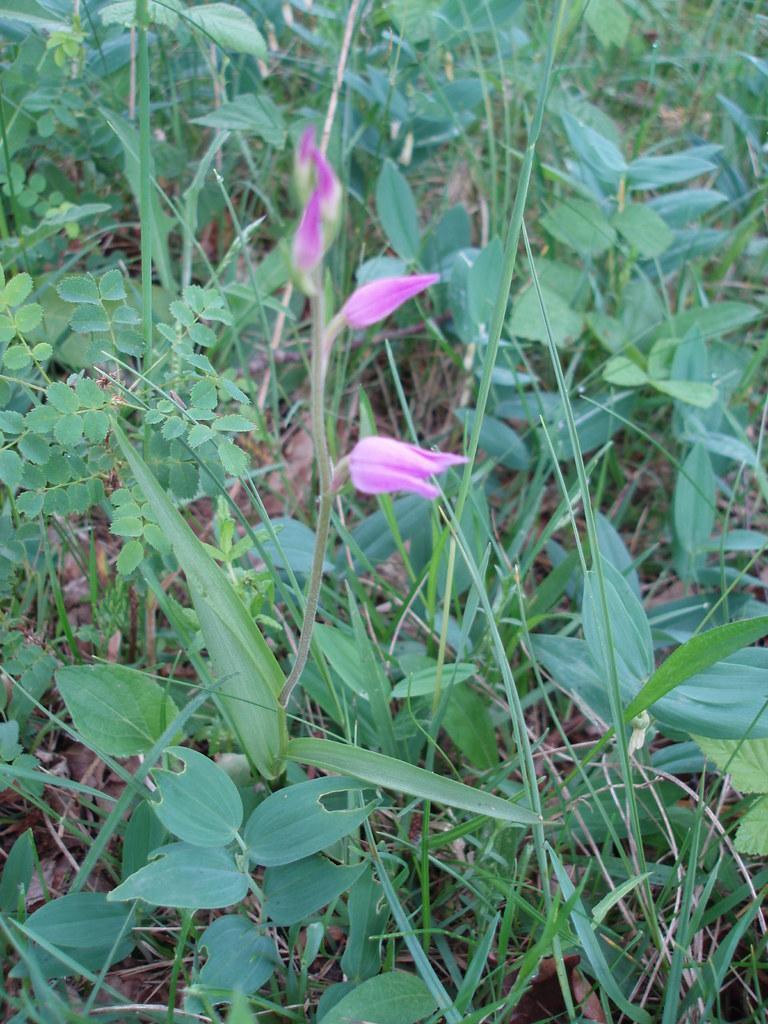In one or two sentences, can you explain what this image depicts? In the foreground of this image, there are three flowers to a plant and we can also see grass and plants. 